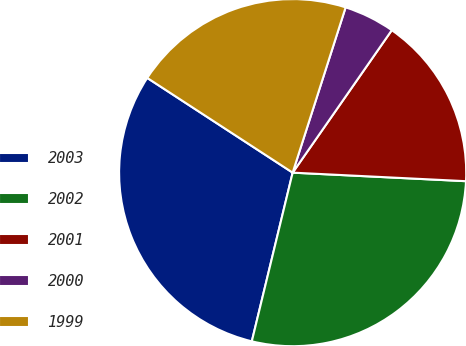Convert chart. <chart><loc_0><loc_0><loc_500><loc_500><pie_chart><fcel>2003<fcel>2002<fcel>2001<fcel>2000<fcel>1999<nl><fcel>30.41%<fcel>28.0%<fcel>16.11%<fcel>4.74%<fcel>20.75%<nl></chart> 